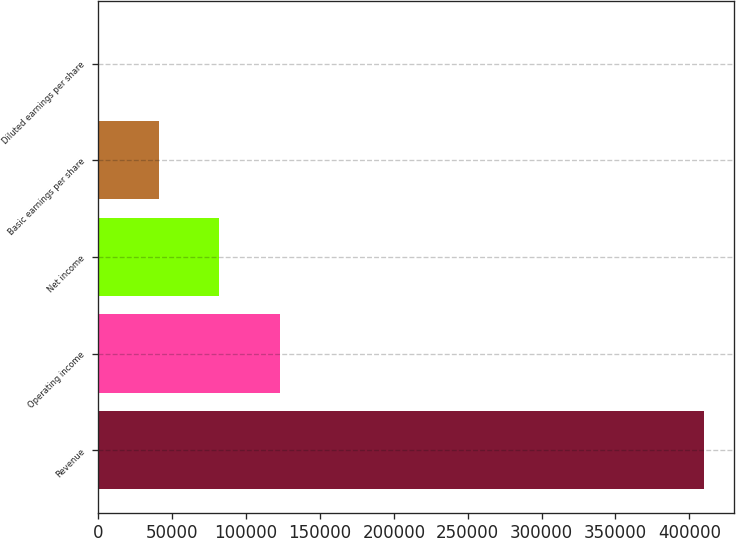Convert chart to OTSL. <chart><loc_0><loc_0><loc_500><loc_500><bar_chart><fcel>Revenue<fcel>Operating income<fcel>Net income<fcel>Basic earnings per share<fcel>Diluted earnings per share<nl><fcel>409686<fcel>122907<fcel>81938.1<fcel>40969.7<fcel>1.19<nl></chart> 